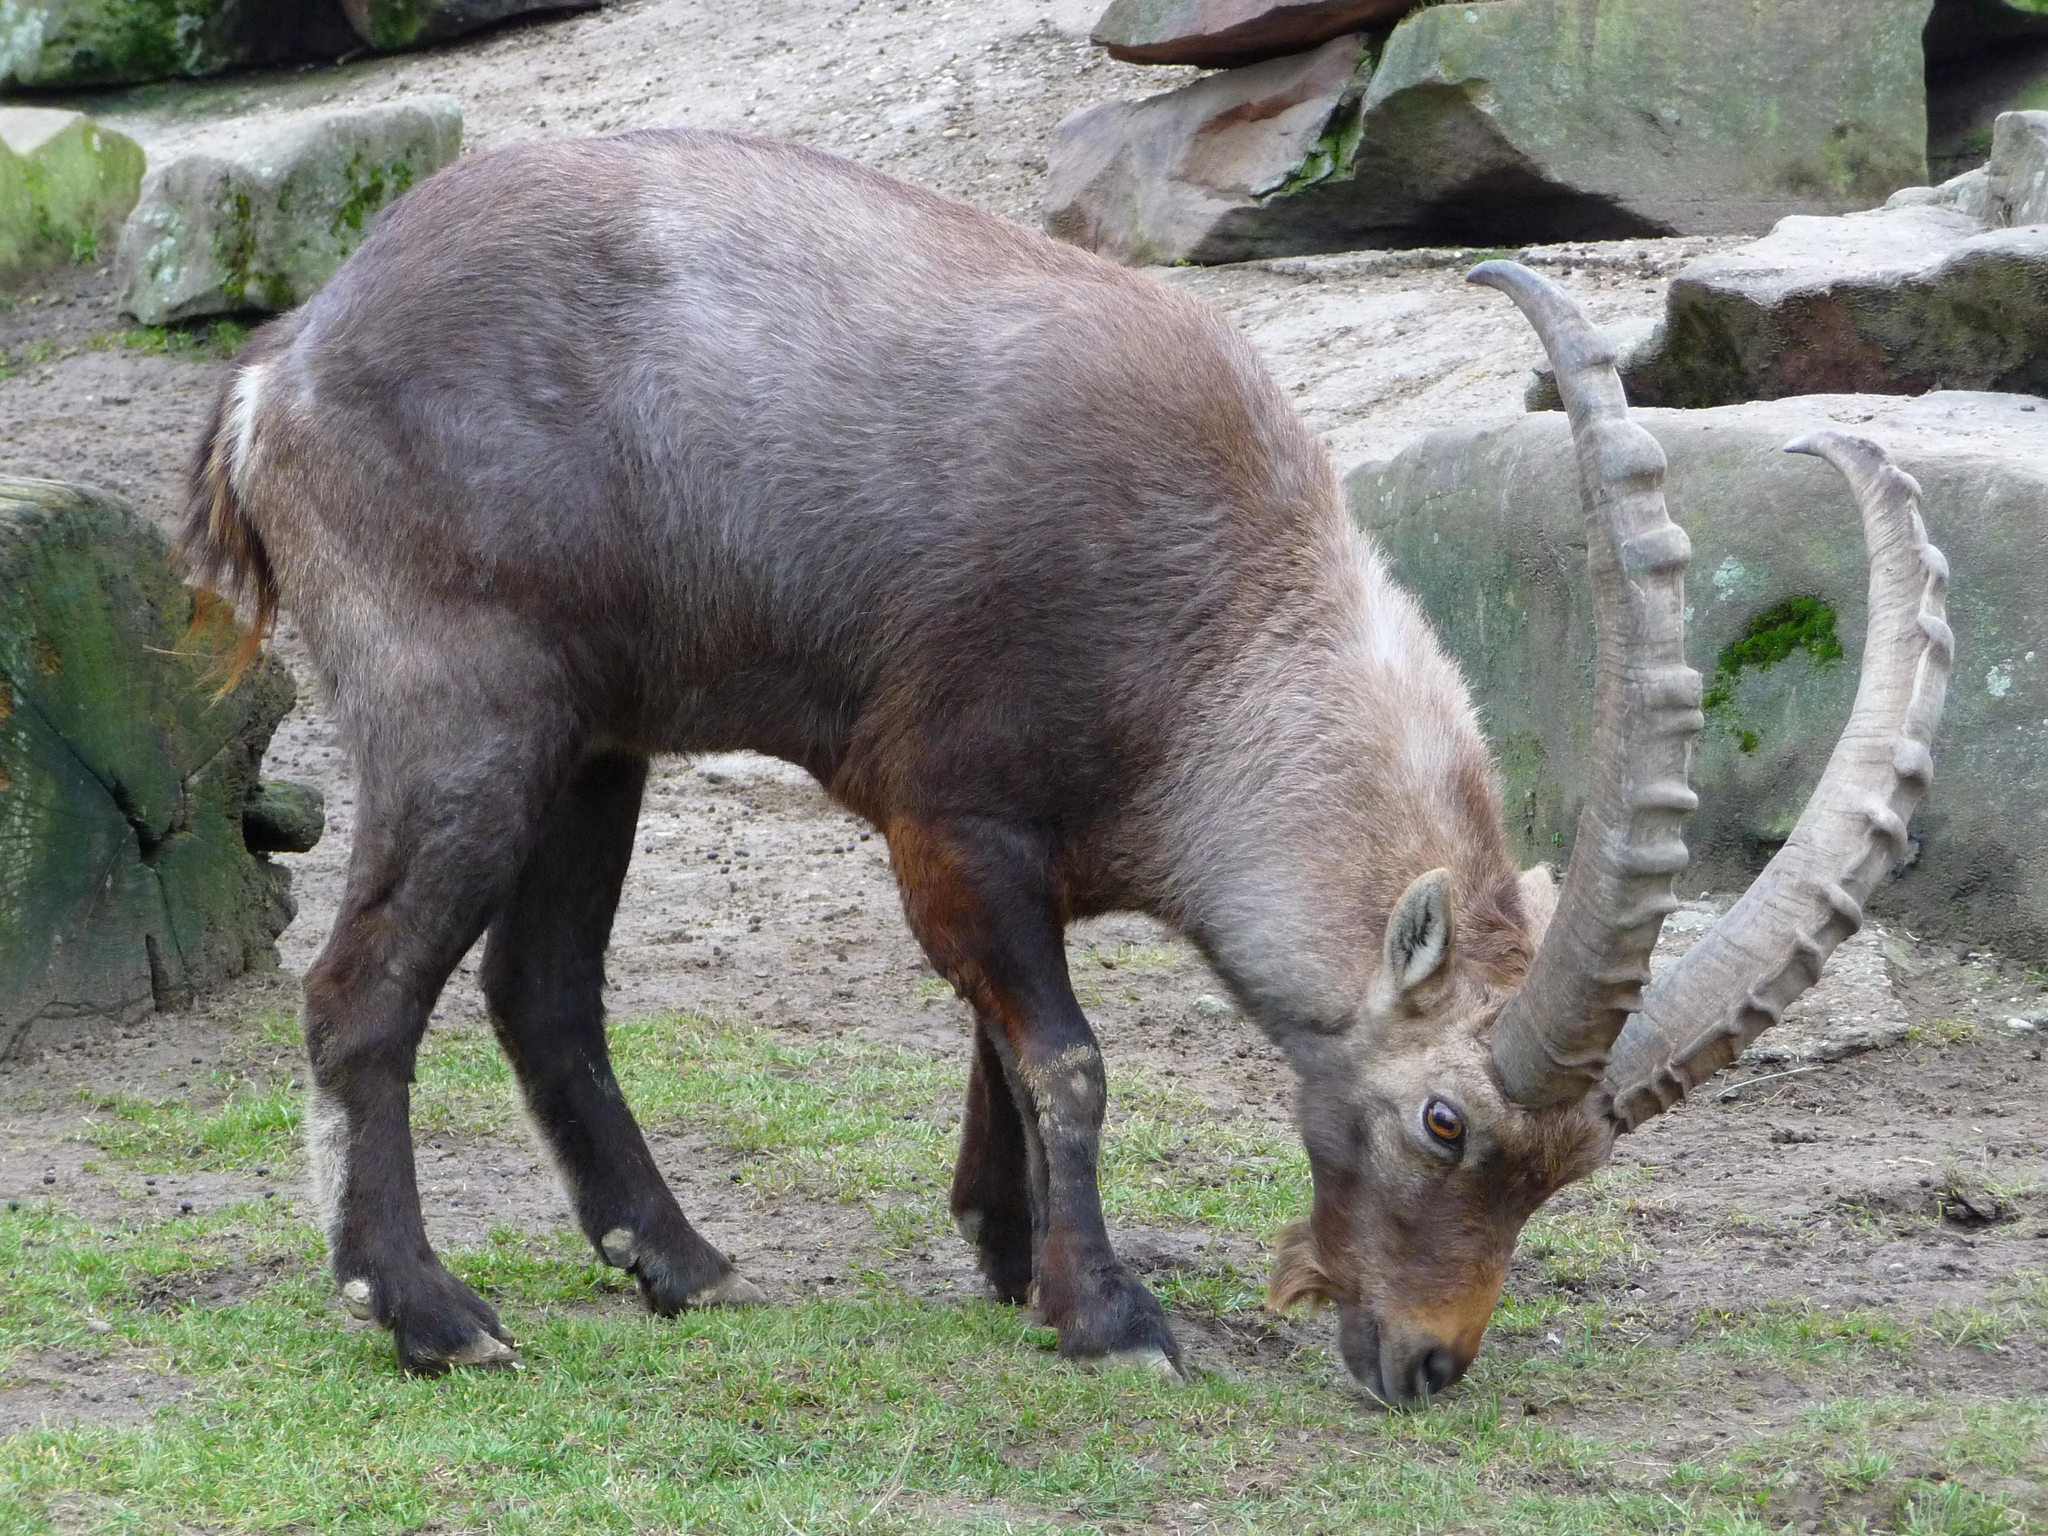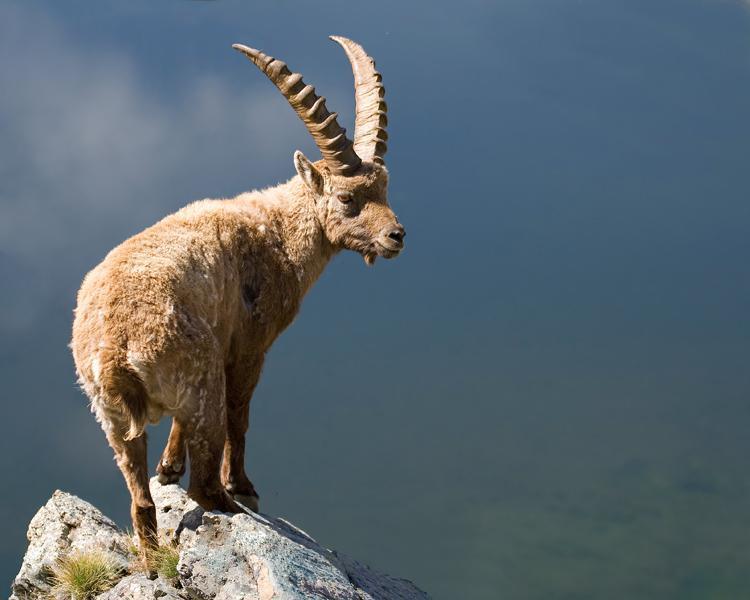The first image is the image on the left, the second image is the image on the right. Considering the images on both sides, is "The horned animals in the right and left images face the same general direction, and at least one animal is reclining on the ground." valid? Answer yes or no. No. 